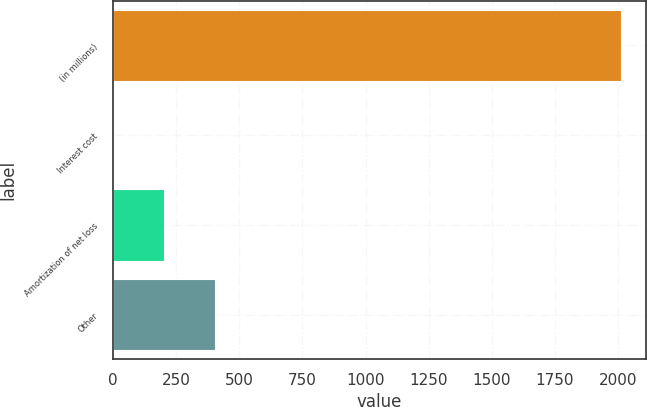Convert chart. <chart><loc_0><loc_0><loc_500><loc_500><bar_chart><fcel>(in millions)<fcel>Interest cost<fcel>Amortization of net loss<fcel>Other<nl><fcel>2011<fcel>2<fcel>202.9<fcel>403.8<nl></chart> 